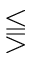Convert formula to latex. <formula><loc_0><loc_0><loc_500><loc_500>\leq s s e q q g t r</formula> 